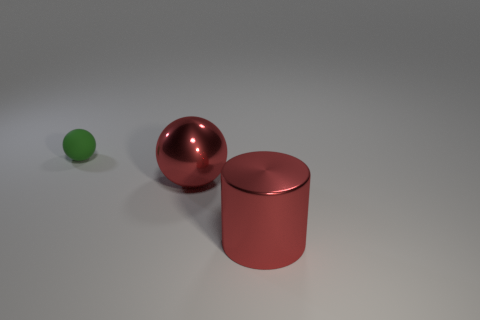What size is the object that is made of the same material as the cylinder?
Your answer should be compact. Large. There is a object that is the same size as the red metallic cylinder; what color is it?
Keep it short and to the point. Red. The other object that is the same shape as the small matte thing is what size?
Your response must be concise. Large. There is a big object in front of the metal sphere; what is its shape?
Your answer should be compact. Cylinder. Is the shape of the green matte object the same as the large red object that is left of the large red cylinder?
Give a very brief answer. Yes. Are there the same number of objects that are in front of the tiny green rubber thing and things behind the big shiny cylinder?
Your response must be concise. Yes. What is the shape of the shiny object that is the same color as the large shiny sphere?
Ensure brevity in your answer.  Cylinder. There is a shiny object that is behind the big red cylinder; does it have the same color as the rubber thing that is to the left of the red sphere?
Your answer should be compact. No. Is the number of red objects in front of the tiny matte ball greater than the number of brown metal spheres?
Your answer should be very brief. Yes. What is the red cylinder made of?
Make the answer very short. Metal. 